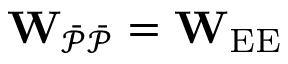<formula> <loc_0><loc_0><loc_500><loc_500>W _ { \mathcal { \ B a r { P } \ B a r { P } } } = W _ { E E }</formula> 